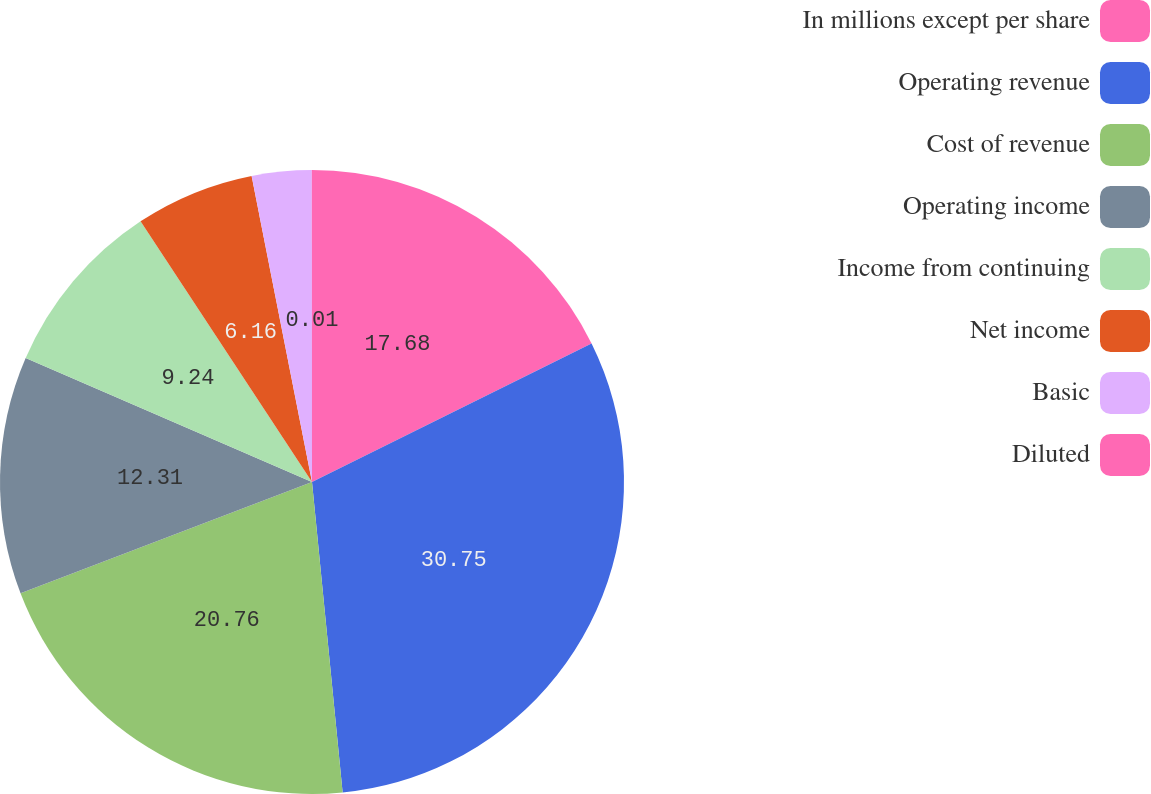<chart> <loc_0><loc_0><loc_500><loc_500><pie_chart><fcel>In millions except per share<fcel>Operating revenue<fcel>Cost of revenue<fcel>Operating income<fcel>Income from continuing<fcel>Net income<fcel>Basic<fcel>Diluted<nl><fcel>17.68%<fcel>30.76%<fcel>20.76%<fcel>12.31%<fcel>9.24%<fcel>6.16%<fcel>3.09%<fcel>0.01%<nl></chart> 